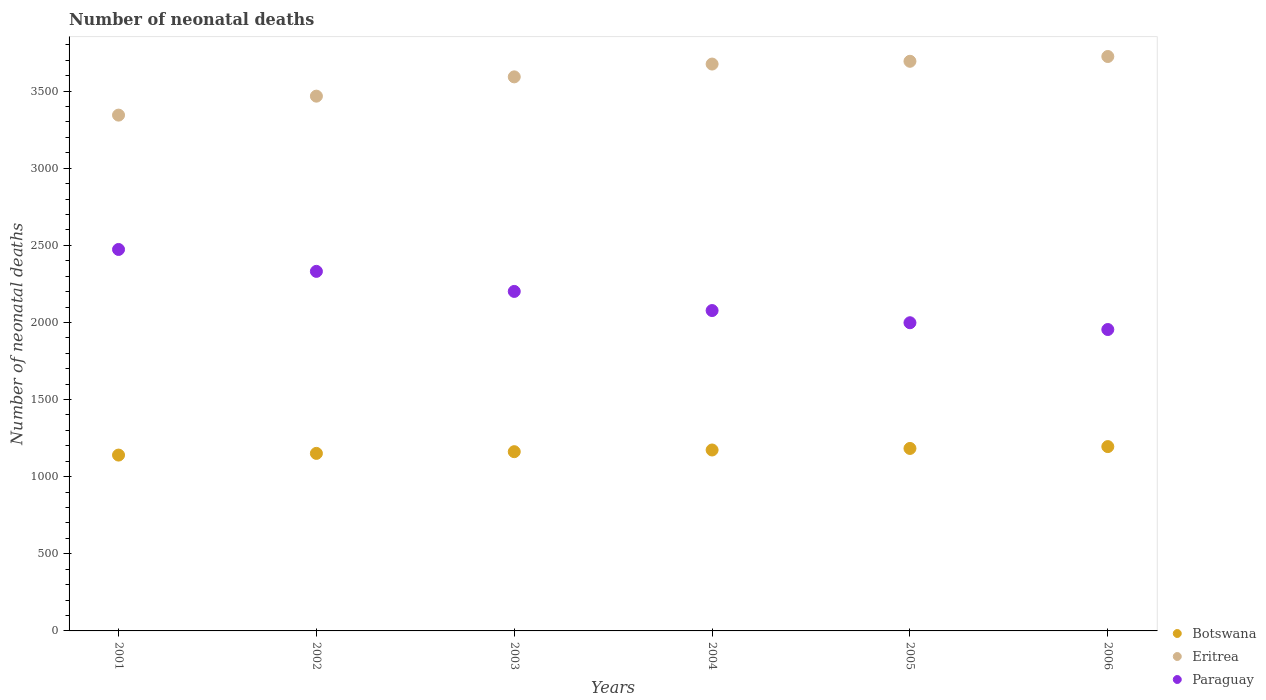How many different coloured dotlines are there?
Your response must be concise. 3. Is the number of dotlines equal to the number of legend labels?
Offer a terse response. Yes. What is the number of neonatal deaths in in Eritrea in 2006?
Make the answer very short. 3724. Across all years, what is the maximum number of neonatal deaths in in Paraguay?
Provide a short and direct response. 2473. Across all years, what is the minimum number of neonatal deaths in in Eritrea?
Provide a succinct answer. 3344. What is the total number of neonatal deaths in in Botswana in the graph?
Your answer should be very brief. 7004. What is the difference between the number of neonatal deaths in in Botswana in 2002 and that in 2003?
Your response must be concise. -11. What is the difference between the number of neonatal deaths in in Botswana in 2006 and the number of neonatal deaths in in Paraguay in 2002?
Give a very brief answer. -1136. What is the average number of neonatal deaths in in Eritrea per year?
Offer a terse response. 3582.5. In the year 2004, what is the difference between the number of neonatal deaths in in Paraguay and number of neonatal deaths in in Eritrea?
Ensure brevity in your answer.  -1598. What is the ratio of the number of neonatal deaths in in Eritrea in 2002 to that in 2006?
Offer a very short reply. 0.93. Is the number of neonatal deaths in in Eritrea in 2002 less than that in 2006?
Make the answer very short. Yes. Is the difference between the number of neonatal deaths in in Paraguay in 2001 and 2006 greater than the difference between the number of neonatal deaths in in Eritrea in 2001 and 2006?
Keep it short and to the point. Yes. What is the difference between the highest and the lowest number of neonatal deaths in in Paraguay?
Offer a terse response. 519. Is the sum of the number of neonatal deaths in in Eritrea in 2001 and 2004 greater than the maximum number of neonatal deaths in in Paraguay across all years?
Provide a short and direct response. Yes. Is it the case that in every year, the sum of the number of neonatal deaths in in Eritrea and number of neonatal deaths in in Botswana  is greater than the number of neonatal deaths in in Paraguay?
Your answer should be compact. Yes. Is the number of neonatal deaths in in Botswana strictly greater than the number of neonatal deaths in in Eritrea over the years?
Your response must be concise. No. Is the number of neonatal deaths in in Eritrea strictly less than the number of neonatal deaths in in Paraguay over the years?
Your answer should be very brief. No. How many dotlines are there?
Offer a terse response. 3. How many years are there in the graph?
Your response must be concise. 6. Are the values on the major ticks of Y-axis written in scientific E-notation?
Keep it short and to the point. No. Does the graph contain any zero values?
Ensure brevity in your answer.  No. Does the graph contain grids?
Offer a terse response. No. Where does the legend appear in the graph?
Make the answer very short. Bottom right. How many legend labels are there?
Your response must be concise. 3. How are the legend labels stacked?
Keep it short and to the point. Vertical. What is the title of the graph?
Offer a very short reply. Number of neonatal deaths. Does "Bosnia and Herzegovina" appear as one of the legend labels in the graph?
Make the answer very short. No. What is the label or title of the Y-axis?
Your answer should be very brief. Number of neonatal deaths. What is the Number of neonatal deaths in Botswana in 2001?
Provide a succinct answer. 1140. What is the Number of neonatal deaths in Eritrea in 2001?
Give a very brief answer. 3344. What is the Number of neonatal deaths in Paraguay in 2001?
Offer a terse response. 2473. What is the Number of neonatal deaths in Botswana in 2002?
Provide a succinct answer. 1151. What is the Number of neonatal deaths in Eritrea in 2002?
Give a very brief answer. 3467. What is the Number of neonatal deaths in Paraguay in 2002?
Offer a terse response. 2331. What is the Number of neonatal deaths in Botswana in 2003?
Offer a very short reply. 1162. What is the Number of neonatal deaths of Eritrea in 2003?
Provide a short and direct response. 3592. What is the Number of neonatal deaths of Paraguay in 2003?
Your response must be concise. 2201. What is the Number of neonatal deaths of Botswana in 2004?
Your answer should be compact. 1173. What is the Number of neonatal deaths of Eritrea in 2004?
Give a very brief answer. 3675. What is the Number of neonatal deaths of Paraguay in 2004?
Provide a short and direct response. 2077. What is the Number of neonatal deaths of Botswana in 2005?
Provide a succinct answer. 1183. What is the Number of neonatal deaths of Eritrea in 2005?
Ensure brevity in your answer.  3693. What is the Number of neonatal deaths in Paraguay in 2005?
Offer a very short reply. 1998. What is the Number of neonatal deaths in Botswana in 2006?
Your response must be concise. 1195. What is the Number of neonatal deaths in Eritrea in 2006?
Ensure brevity in your answer.  3724. What is the Number of neonatal deaths in Paraguay in 2006?
Offer a very short reply. 1954. Across all years, what is the maximum Number of neonatal deaths of Botswana?
Make the answer very short. 1195. Across all years, what is the maximum Number of neonatal deaths of Eritrea?
Your answer should be very brief. 3724. Across all years, what is the maximum Number of neonatal deaths of Paraguay?
Ensure brevity in your answer.  2473. Across all years, what is the minimum Number of neonatal deaths of Botswana?
Offer a very short reply. 1140. Across all years, what is the minimum Number of neonatal deaths of Eritrea?
Your answer should be very brief. 3344. Across all years, what is the minimum Number of neonatal deaths of Paraguay?
Your answer should be compact. 1954. What is the total Number of neonatal deaths in Botswana in the graph?
Your response must be concise. 7004. What is the total Number of neonatal deaths in Eritrea in the graph?
Offer a very short reply. 2.15e+04. What is the total Number of neonatal deaths in Paraguay in the graph?
Make the answer very short. 1.30e+04. What is the difference between the Number of neonatal deaths in Botswana in 2001 and that in 2002?
Keep it short and to the point. -11. What is the difference between the Number of neonatal deaths of Eritrea in 2001 and that in 2002?
Provide a short and direct response. -123. What is the difference between the Number of neonatal deaths in Paraguay in 2001 and that in 2002?
Ensure brevity in your answer.  142. What is the difference between the Number of neonatal deaths in Eritrea in 2001 and that in 2003?
Provide a succinct answer. -248. What is the difference between the Number of neonatal deaths in Paraguay in 2001 and that in 2003?
Offer a terse response. 272. What is the difference between the Number of neonatal deaths of Botswana in 2001 and that in 2004?
Your answer should be compact. -33. What is the difference between the Number of neonatal deaths of Eritrea in 2001 and that in 2004?
Offer a very short reply. -331. What is the difference between the Number of neonatal deaths of Paraguay in 2001 and that in 2004?
Provide a short and direct response. 396. What is the difference between the Number of neonatal deaths of Botswana in 2001 and that in 2005?
Provide a short and direct response. -43. What is the difference between the Number of neonatal deaths in Eritrea in 2001 and that in 2005?
Keep it short and to the point. -349. What is the difference between the Number of neonatal deaths of Paraguay in 2001 and that in 2005?
Your response must be concise. 475. What is the difference between the Number of neonatal deaths in Botswana in 2001 and that in 2006?
Your response must be concise. -55. What is the difference between the Number of neonatal deaths in Eritrea in 2001 and that in 2006?
Ensure brevity in your answer.  -380. What is the difference between the Number of neonatal deaths of Paraguay in 2001 and that in 2006?
Your answer should be compact. 519. What is the difference between the Number of neonatal deaths in Botswana in 2002 and that in 2003?
Make the answer very short. -11. What is the difference between the Number of neonatal deaths in Eritrea in 2002 and that in 2003?
Provide a short and direct response. -125. What is the difference between the Number of neonatal deaths in Paraguay in 2002 and that in 2003?
Provide a succinct answer. 130. What is the difference between the Number of neonatal deaths in Botswana in 2002 and that in 2004?
Provide a short and direct response. -22. What is the difference between the Number of neonatal deaths in Eritrea in 2002 and that in 2004?
Your answer should be compact. -208. What is the difference between the Number of neonatal deaths of Paraguay in 2002 and that in 2004?
Provide a succinct answer. 254. What is the difference between the Number of neonatal deaths in Botswana in 2002 and that in 2005?
Your answer should be compact. -32. What is the difference between the Number of neonatal deaths of Eritrea in 2002 and that in 2005?
Offer a very short reply. -226. What is the difference between the Number of neonatal deaths of Paraguay in 2002 and that in 2005?
Provide a succinct answer. 333. What is the difference between the Number of neonatal deaths of Botswana in 2002 and that in 2006?
Ensure brevity in your answer.  -44. What is the difference between the Number of neonatal deaths of Eritrea in 2002 and that in 2006?
Your response must be concise. -257. What is the difference between the Number of neonatal deaths of Paraguay in 2002 and that in 2006?
Provide a succinct answer. 377. What is the difference between the Number of neonatal deaths of Eritrea in 2003 and that in 2004?
Offer a very short reply. -83. What is the difference between the Number of neonatal deaths of Paraguay in 2003 and that in 2004?
Offer a very short reply. 124. What is the difference between the Number of neonatal deaths in Botswana in 2003 and that in 2005?
Provide a succinct answer. -21. What is the difference between the Number of neonatal deaths of Eritrea in 2003 and that in 2005?
Ensure brevity in your answer.  -101. What is the difference between the Number of neonatal deaths of Paraguay in 2003 and that in 2005?
Give a very brief answer. 203. What is the difference between the Number of neonatal deaths in Botswana in 2003 and that in 2006?
Make the answer very short. -33. What is the difference between the Number of neonatal deaths in Eritrea in 2003 and that in 2006?
Provide a succinct answer. -132. What is the difference between the Number of neonatal deaths of Paraguay in 2003 and that in 2006?
Keep it short and to the point. 247. What is the difference between the Number of neonatal deaths in Botswana in 2004 and that in 2005?
Your answer should be compact. -10. What is the difference between the Number of neonatal deaths in Eritrea in 2004 and that in 2005?
Make the answer very short. -18. What is the difference between the Number of neonatal deaths of Paraguay in 2004 and that in 2005?
Offer a very short reply. 79. What is the difference between the Number of neonatal deaths in Botswana in 2004 and that in 2006?
Your answer should be compact. -22. What is the difference between the Number of neonatal deaths in Eritrea in 2004 and that in 2006?
Your answer should be very brief. -49. What is the difference between the Number of neonatal deaths in Paraguay in 2004 and that in 2006?
Ensure brevity in your answer.  123. What is the difference between the Number of neonatal deaths in Botswana in 2005 and that in 2006?
Your response must be concise. -12. What is the difference between the Number of neonatal deaths of Eritrea in 2005 and that in 2006?
Keep it short and to the point. -31. What is the difference between the Number of neonatal deaths in Botswana in 2001 and the Number of neonatal deaths in Eritrea in 2002?
Keep it short and to the point. -2327. What is the difference between the Number of neonatal deaths of Botswana in 2001 and the Number of neonatal deaths of Paraguay in 2002?
Make the answer very short. -1191. What is the difference between the Number of neonatal deaths in Eritrea in 2001 and the Number of neonatal deaths in Paraguay in 2002?
Make the answer very short. 1013. What is the difference between the Number of neonatal deaths in Botswana in 2001 and the Number of neonatal deaths in Eritrea in 2003?
Provide a succinct answer. -2452. What is the difference between the Number of neonatal deaths in Botswana in 2001 and the Number of neonatal deaths in Paraguay in 2003?
Make the answer very short. -1061. What is the difference between the Number of neonatal deaths in Eritrea in 2001 and the Number of neonatal deaths in Paraguay in 2003?
Your answer should be very brief. 1143. What is the difference between the Number of neonatal deaths of Botswana in 2001 and the Number of neonatal deaths of Eritrea in 2004?
Provide a succinct answer. -2535. What is the difference between the Number of neonatal deaths of Botswana in 2001 and the Number of neonatal deaths of Paraguay in 2004?
Offer a terse response. -937. What is the difference between the Number of neonatal deaths of Eritrea in 2001 and the Number of neonatal deaths of Paraguay in 2004?
Ensure brevity in your answer.  1267. What is the difference between the Number of neonatal deaths of Botswana in 2001 and the Number of neonatal deaths of Eritrea in 2005?
Your answer should be compact. -2553. What is the difference between the Number of neonatal deaths in Botswana in 2001 and the Number of neonatal deaths in Paraguay in 2005?
Give a very brief answer. -858. What is the difference between the Number of neonatal deaths of Eritrea in 2001 and the Number of neonatal deaths of Paraguay in 2005?
Provide a short and direct response. 1346. What is the difference between the Number of neonatal deaths in Botswana in 2001 and the Number of neonatal deaths in Eritrea in 2006?
Give a very brief answer. -2584. What is the difference between the Number of neonatal deaths in Botswana in 2001 and the Number of neonatal deaths in Paraguay in 2006?
Ensure brevity in your answer.  -814. What is the difference between the Number of neonatal deaths of Eritrea in 2001 and the Number of neonatal deaths of Paraguay in 2006?
Your answer should be very brief. 1390. What is the difference between the Number of neonatal deaths in Botswana in 2002 and the Number of neonatal deaths in Eritrea in 2003?
Provide a short and direct response. -2441. What is the difference between the Number of neonatal deaths in Botswana in 2002 and the Number of neonatal deaths in Paraguay in 2003?
Make the answer very short. -1050. What is the difference between the Number of neonatal deaths of Eritrea in 2002 and the Number of neonatal deaths of Paraguay in 2003?
Your answer should be compact. 1266. What is the difference between the Number of neonatal deaths in Botswana in 2002 and the Number of neonatal deaths in Eritrea in 2004?
Provide a succinct answer. -2524. What is the difference between the Number of neonatal deaths in Botswana in 2002 and the Number of neonatal deaths in Paraguay in 2004?
Provide a short and direct response. -926. What is the difference between the Number of neonatal deaths of Eritrea in 2002 and the Number of neonatal deaths of Paraguay in 2004?
Ensure brevity in your answer.  1390. What is the difference between the Number of neonatal deaths of Botswana in 2002 and the Number of neonatal deaths of Eritrea in 2005?
Your answer should be compact. -2542. What is the difference between the Number of neonatal deaths of Botswana in 2002 and the Number of neonatal deaths of Paraguay in 2005?
Offer a very short reply. -847. What is the difference between the Number of neonatal deaths in Eritrea in 2002 and the Number of neonatal deaths in Paraguay in 2005?
Your answer should be compact. 1469. What is the difference between the Number of neonatal deaths in Botswana in 2002 and the Number of neonatal deaths in Eritrea in 2006?
Your answer should be very brief. -2573. What is the difference between the Number of neonatal deaths in Botswana in 2002 and the Number of neonatal deaths in Paraguay in 2006?
Ensure brevity in your answer.  -803. What is the difference between the Number of neonatal deaths in Eritrea in 2002 and the Number of neonatal deaths in Paraguay in 2006?
Offer a terse response. 1513. What is the difference between the Number of neonatal deaths in Botswana in 2003 and the Number of neonatal deaths in Eritrea in 2004?
Ensure brevity in your answer.  -2513. What is the difference between the Number of neonatal deaths in Botswana in 2003 and the Number of neonatal deaths in Paraguay in 2004?
Keep it short and to the point. -915. What is the difference between the Number of neonatal deaths of Eritrea in 2003 and the Number of neonatal deaths of Paraguay in 2004?
Your response must be concise. 1515. What is the difference between the Number of neonatal deaths of Botswana in 2003 and the Number of neonatal deaths of Eritrea in 2005?
Your response must be concise. -2531. What is the difference between the Number of neonatal deaths in Botswana in 2003 and the Number of neonatal deaths in Paraguay in 2005?
Make the answer very short. -836. What is the difference between the Number of neonatal deaths in Eritrea in 2003 and the Number of neonatal deaths in Paraguay in 2005?
Offer a terse response. 1594. What is the difference between the Number of neonatal deaths in Botswana in 2003 and the Number of neonatal deaths in Eritrea in 2006?
Your response must be concise. -2562. What is the difference between the Number of neonatal deaths in Botswana in 2003 and the Number of neonatal deaths in Paraguay in 2006?
Ensure brevity in your answer.  -792. What is the difference between the Number of neonatal deaths in Eritrea in 2003 and the Number of neonatal deaths in Paraguay in 2006?
Provide a short and direct response. 1638. What is the difference between the Number of neonatal deaths in Botswana in 2004 and the Number of neonatal deaths in Eritrea in 2005?
Keep it short and to the point. -2520. What is the difference between the Number of neonatal deaths in Botswana in 2004 and the Number of neonatal deaths in Paraguay in 2005?
Provide a succinct answer. -825. What is the difference between the Number of neonatal deaths of Eritrea in 2004 and the Number of neonatal deaths of Paraguay in 2005?
Keep it short and to the point. 1677. What is the difference between the Number of neonatal deaths in Botswana in 2004 and the Number of neonatal deaths in Eritrea in 2006?
Make the answer very short. -2551. What is the difference between the Number of neonatal deaths of Botswana in 2004 and the Number of neonatal deaths of Paraguay in 2006?
Make the answer very short. -781. What is the difference between the Number of neonatal deaths in Eritrea in 2004 and the Number of neonatal deaths in Paraguay in 2006?
Your answer should be very brief. 1721. What is the difference between the Number of neonatal deaths of Botswana in 2005 and the Number of neonatal deaths of Eritrea in 2006?
Your answer should be very brief. -2541. What is the difference between the Number of neonatal deaths of Botswana in 2005 and the Number of neonatal deaths of Paraguay in 2006?
Your answer should be very brief. -771. What is the difference between the Number of neonatal deaths of Eritrea in 2005 and the Number of neonatal deaths of Paraguay in 2006?
Offer a very short reply. 1739. What is the average Number of neonatal deaths of Botswana per year?
Provide a succinct answer. 1167.33. What is the average Number of neonatal deaths in Eritrea per year?
Make the answer very short. 3582.5. What is the average Number of neonatal deaths in Paraguay per year?
Make the answer very short. 2172.33. In the year 2001, what is the difference between the Number of neonatal deaths in Botswana and Number of neonatal deaths in Eritrea?
Your answer should be very brief. -2204. In the year 2001, what is the difference between the Number of neonatal deaths in Botswana and Number of neonatal deaths in Paraguay?
Ensure brevity in your answer.  -1333. In the year 2001, what is the difference between the Number of neonatal deaths of Eritrea and Number of neonatal deaths of Paraguay?
Provide a short and direct response. 871. In the year 2002, what is the difference between the Number of neonatal deaths in Botswana and Number of neonatal deaths in Eritrea?
Provide a succinct answer. -2316. In the year 2002, what is the difference between the Number of neonatal deaths of Botswana and Number of neonatal deaths of Paraguay?
Offer a terse response. -1180. In the year 2002, what is the difference between the Number of neonatal deaths in Eritrea and Number of neonatal deaths in Paraguay?
Give a very brief answer. 1136. In the year 2003, what is the difference between the Number of neonatal deaths in Botswana and Number of neonatal deaths in Eritrea?
Make the answer very short. -2430. In the year 2003, what is the difference between the Number of neonatal deaths in Botswana and Number of neonatal deaths in Paraguay?
Provide a succinct answer. -1039. In the year 2003, what is the difference between the Number of neonatal deaths in Eritrea and Number of neonatal deaths in Paraguay?
Your answer should be compact. 1391. In the year 2004, what is the difference between the Number of neonatal deaths of Botswana and Number of neonatal deaths of Eritrea?
Give a very brief answer. -2502. In the year 2004, what is the difference between the Number of neonatal deaths in Botswana and Number of neonatal deaths in Paraguay?
Your response must be concise. -904. In the year 2004, what is the difference between the Number of neonatal deaths of Eritrea and Number of neonatal deaths of Paraguay?
Your answer should be compact. 1598. In the year 2005, what is the difference between the Number of neonatal deaths in Botswana and Number of neonatal deaths in Eritrea?
Your response must be concise. -2510. In the year 2005, what is the difference between the Number of neonatal deaths of Botswana and Number of neonatal deaths of Paraguay?
Give a very brief answer. -815. In the year 2005, what is the difference between the Number of neonatal deaths of Eritrea and Number of neonatal deaths of Paraguay?
Offer a very short reply. 1695. In the year 2006, what is the difference between the Number of neonatal deaths in Botswana and Number of neonatal deaths in Eritrea?
Keep it short and to the point. -2529. In the year 2006, what is the difference between the Number of neonatal deaths of Botswana and Number of neonatal deaths of Paraguay?
Make the answer very short. -759. In the year 2006, what is the difference between the Number of neonatal deaths of Eritrea and Number of neonatal deaths of Paraguay?
Your answer should be compact. 1770. What is the ratio of the Number of neonatal deaths in Eritrea in 2001 to that in 2002?
Give a very brief answer. 0.96. What is the ratio of the Number of neonatal deaths of Paraguay in 2001 to that in 2002?
Give a very brief answer. 1.06. What is the ratio of the Number of neonatal deaths in Botswana in 2001 to that in 2003?
Keep it short and to the point. 0.98. What is the ratio of the Number of neonatal deaths in Paraguay in 2001 to that in 2003?
Give a very brief answer. 1.12. What is the ratio of the Number of neonatal deaths in Botswana in 2001 to that in 2004?
Ensure brevity in your answer.  0.97. What is the ratio of the Number of neonatal deaths in Eritrea in 2001 to that in 2004?
Give a very brief answer. 0.91. What is the ratio of the Number of neonatal deaths in Paraguay in 2001 to that in 2004?
Your response must be concise. 1.19. What is the ratio of the Number of neonatal deaths in Botswana in 2001 to that in 2005?
Ensure brevity in your answer.  0.96. What is the ratio of the Number of neonatal deaths of Eritrea in 2001 to that in 2005?
Offer a terse response. 0.91. What is the ratio of the Number of neonatal deaths of Paraguay in 2001 to that in 2005?
Keep it short and to the point. 1.24. What is the ratio of the Number of neonatal deaths of Botswana in 2001 to that in 2006?
Your answer should be compact. 0.95. What is the ratio of the Number of neonatal deaths of Eritrea in 2001 to that in 2006?
Give a very brief answer. 0.9. What is the ratio of the Number of neonatal deaths of Paraguay in 2001 to that in 2006?
Ensure brevity in your answer.  1.27. What is the ratio of the Number of neonatal deaths in Eritrea in 2002 to that in 2003?
Keep it short and to the point. 0.97. What is the ratio of the Number of neonatal deaths in Paraguay in 2002 to that in 2003?
Ensure brevity in your answer.  1.06. What is the ratio of the Number of neonatal deaths of Botswana in 2002 to that in 2004?
Offer a terse response. 0.98. What is the ratio of the Number of neonatal deaths of Eritrea in 2002 to that in 2004?
Offer a very short reply. 0.94. What is the ratio of the Number of neonatal deaths of Paraguay in 2002 to that in 2004?
Ensure brevity in your answer.  1.12. What is the ratio of the Number of neonatal deaths in Eritrea in 2002 to that in 2005?
Your answer should be very brief. 0.94. What is the ratio of the Number of neonatal deaths of Botswana in 2002 to that in 2006?
Give a very brief answer. 0.96. What is the ratio of the Number of neonatal deaths in Eritrea in 2002 to that in 2006?
Make the answer very short. 0.93. What is the ratio of the Number of neonatal deaths in Paraguay in 2002 to that in 2006?
Provide a short and direct response. 1.19. What is the ratio of the Number of neonatal deaths of Botswana in 2003 to that in 2004?
Your response must be concise. 0.99. What is the ratio of the Number of neonatal deaths in Eritrea in 2003 to that in 2004?
Keep it short and to the point. 0.98. What is the ratio of the Number of neonatal deaths in Paraguay in 2003 to that in 2004?
Ensure brevity in your answer.  1.06. What is the ratio of the Number of neonatal deaths of Botswana in 2003 to that in 2005?
Offer a terse response. 0.98. What is the ratio of the Number of neonatal deaths of Eritrea in 2003 to that in 2005?
Offer a terse response. 0.97. What is the ratio of the Number of neonatal deaths in Paraguay in 2003 to that in 2005?
Offer a very short reply. 1.1. What is the ratio of the Number of neonatal deaths in Botswana in 2003 to that in 2006?
Keep it short and to the point. 0.97. What is the ratio of the Number of neonatal deaths in Eritrea in 2003 to that in 2006?
Ensure brevity in your answer.  0.96. What is the ratio of the Number of neonatal deaths of Paraguay in 2003 to that in 2006?
Ensure brevity in your answer.  1.13. What is the ratio of the Number of neonatal deaths in Paraguay in 2004 to that in 2005?
Give a very brief answer. 1.04. What is the ratio of the Number of neonatal deaths of Botswana in 2004 to that in 2006?
Make the answer very short. 0.98. What is the ratio of the Number of neonatal deaths of Paraguay in 2004 to that in 2006?
Ensure brevity in your answer.  1.06. What is the ratio of the Number of neonatal deaths of Eritrea in 2005 to that in 2006?
Provide a succinct answer. 0.99. What is the ratio of the Number of neonatal deaths in Paraguay in 2005 to that in 2006?
Offer a terse response. 1.02. What is the difference between the highest and the second highest Number of neonatal deaths in Paraguay?
Your response must be concise. 142. What is the difference between the highest and the lowest Number of neonatal deaths in Botswana?
Provide a short and direct response. 55. What is the difference between the highest and the lowest Number of neonatal deaths of Eritrea?
Give a very brief answer. 380. What is the difference between the highest and the lowest Number of neonatal deaths in Paraguay?
Offer a terse response. 519. 